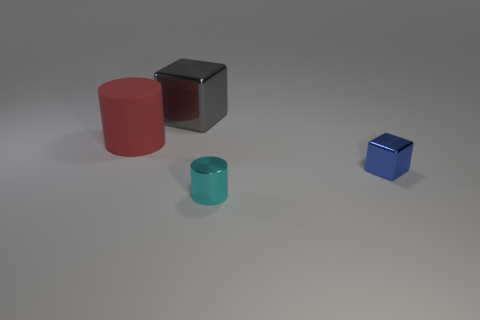Can you infer anything about the lighting conditions in the scene from the shadows and reflections? The lighting in the scene suggests a single diffuse light source coming from above and slightly to the right, as indicated by the soft, faint shadows cast on the left side of the objects. The lack of hard edges on the shadows means the light is not very intense or direct. The reflections on the metallic cube and the semi-transparent cylinder further suggest that the light is not overly bright, providing a balanced illumination that enhances the objects' colors and textures without creating harsh highlights. 